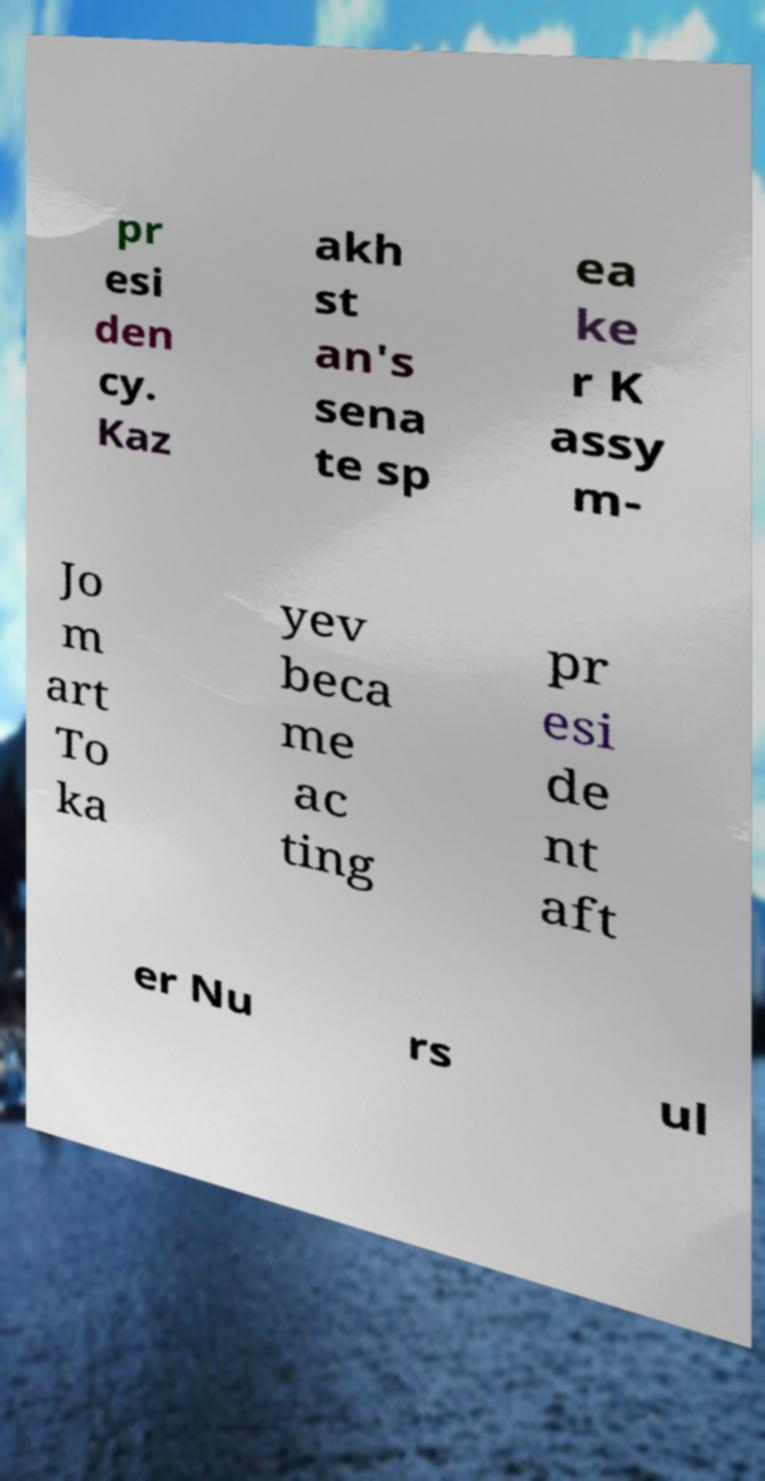Can you read and provide the text displayed in the image?This photo seems to have some interesting text. Can you extract and type it out for me? pr esi den cy. Kaz akh st an's sena te sp ea ke r K assy m- Jo m art To ka yev beca me ac ting pr esi de nt aft er Nu rs ul 